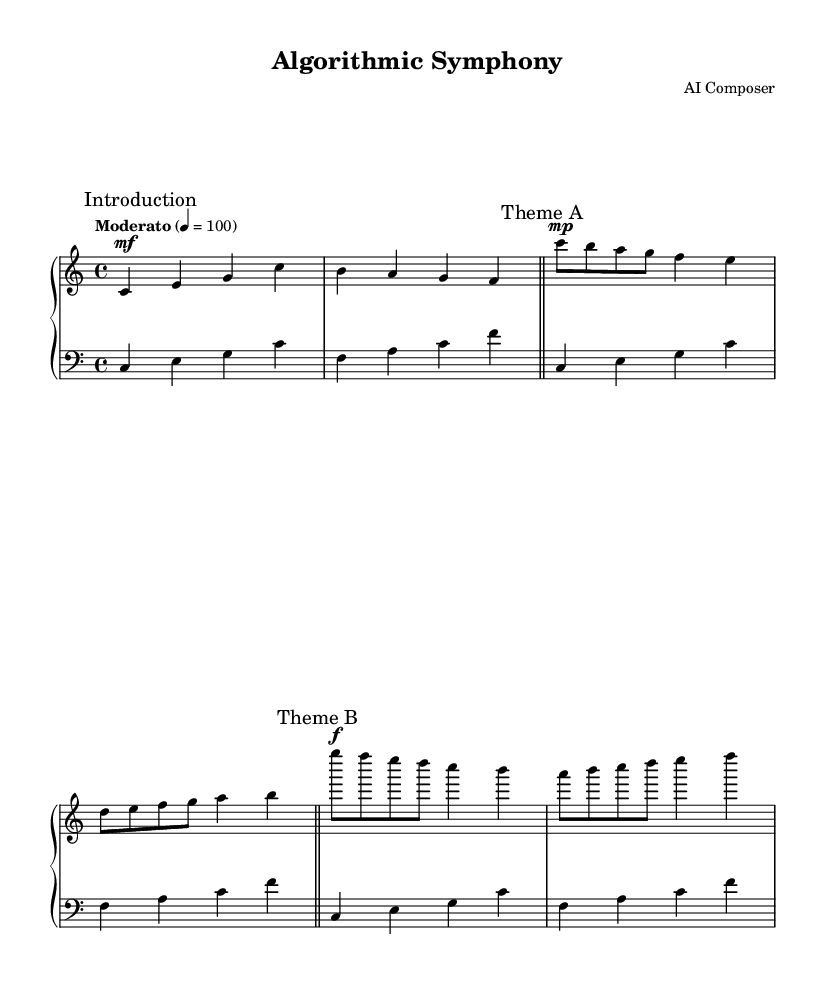What is the key signature of this music? The key signature indicated is C major, which contains no sharps or flats. This can be determined by looking at the key signature at the beginning of the piece.
Answer: C major What is the time signature of this music? The time signature shown is 4/4, which means there are four beats in each measure and the quarter note receives one beat. This is visible in the notational element at the beginning of the score.
Answer: 4/4 What is the tempo marking of this music? The tempo marking states "Moderato," indicating a moderate speed, with a metronome mark of 100 beats per minute. This can be found written above the staff.
Answer: Moderato How many measures are in Theme A? Theme A consists of a total of two complete measures, as indicated by the measure lines separating different sections. Each section's measures can be counted once the theme is marked.
Answer: 2 Which dynamic marking is used at the beginning of Theme B? The dynamic marking for Theme B starts with a forte indication, represented by the 'f' directly in front of the first note of this theme. This shows the intensity with which the music should be played.
Answer: forte What is the main difference in dynamics between Theme A and Theme B? Theme A has a mezzo-piano marking, which means moderately soft, while Theme B transitions to forte, suggesting a change to loud. This shows a contrast between the two sections based on the dynamic marks provided.
Answer: Mezzo-piano and forte What is the rhythmic pattern used in the bass line? The bass line features a rhythmic pattern primarily composed of quarter notes, which establishes a steady foundation throughout the piece. This is observable by examining the repeated notes and their values across the measures.
Answer: Quarter notes 